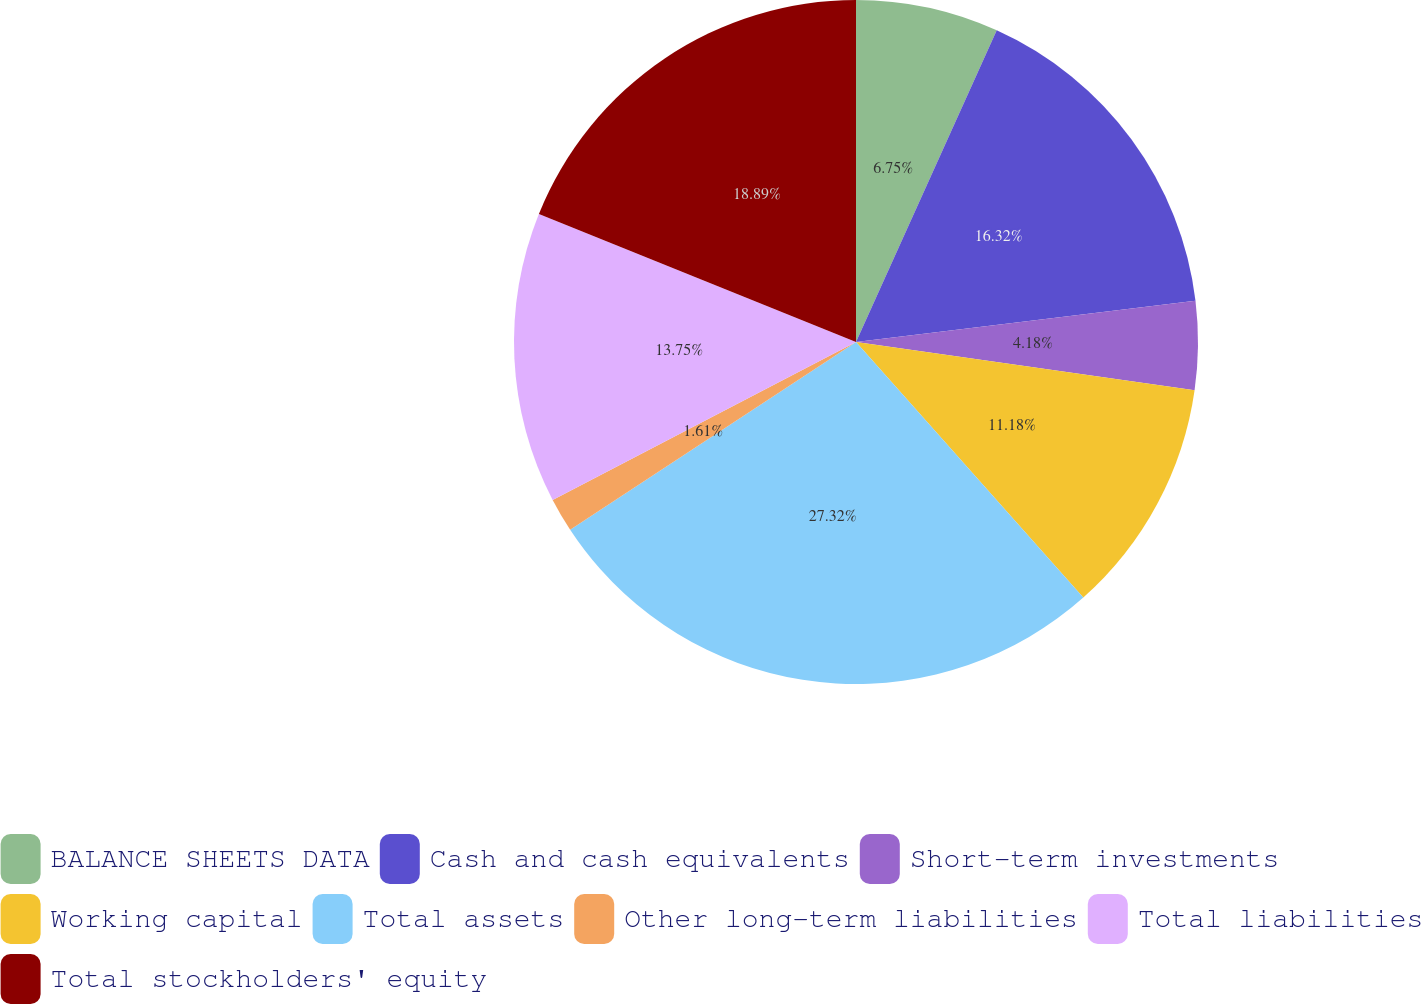Convert chart. <chart><loc_0><loc_0><loc_500><loc_500><pie_chart><fcel>BALANCE SHEETS DATA<fcel>Cash and cash equivalents<fcel>Short-term investments<fcel>Working capital<fcel>Total assets<fcel>Other long-term liabilities<fcel>Total liabilities<fcel>Total stockholders' equity<nl><fcel>6.75%<fcel>16.32%<fcel>4.18%<fcel>11.18%<fcel>27.32%<fcel>1.61%<fcel>13.75%<fcel>18.89%<nl></chart> 